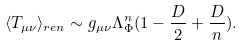Convert formula to latex. <formula><loc_0><loc_0><loc_500><loc_500>\langle T _ { \mu \nu } \rangle _ { r e n } \sim g _ { \mu \nu } \Lambda _ { \Phi } ^ { n } ( 1 - \frac { D } { 2 } + \frac { D } { n } ) .</formula> 